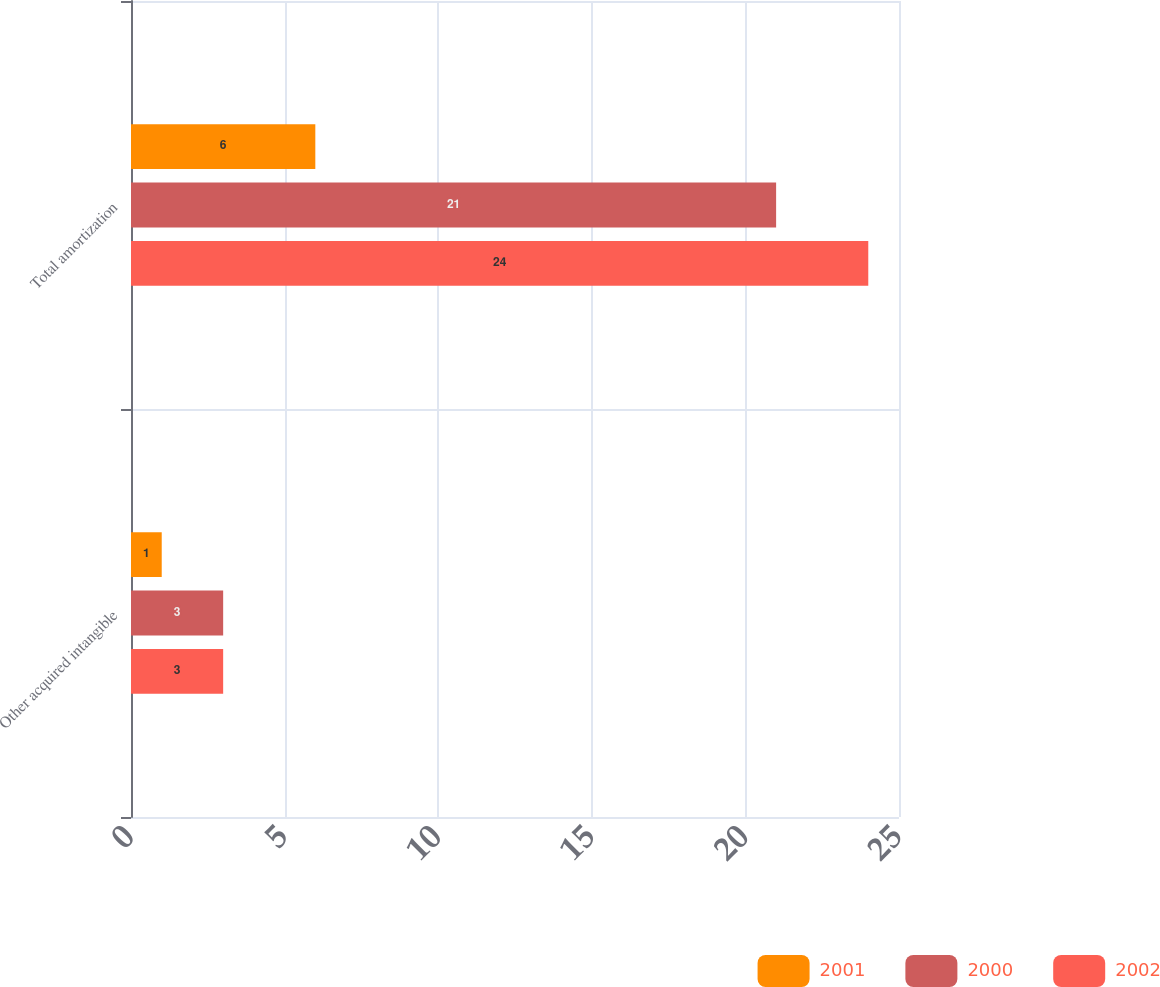Convert chart. <chart><loc_0><loc_0><loc_500><loc_500><stacked_bar_chart><ecel><fcel>Other acquired intangible<fcel>Total amortization<nl><fcel>2001<fcel>1<fcel>6<nl><fcel>2000<fcel>3<fcel>21<nl><fcel>2002<fcel>3<fcel>24<nl></chart> 